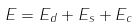Convert formula to latex. <formula><loc_0><loc_0><loc_500><loc_500>E = E _ { d } + E _ { s } + E _ { c }</formula> 